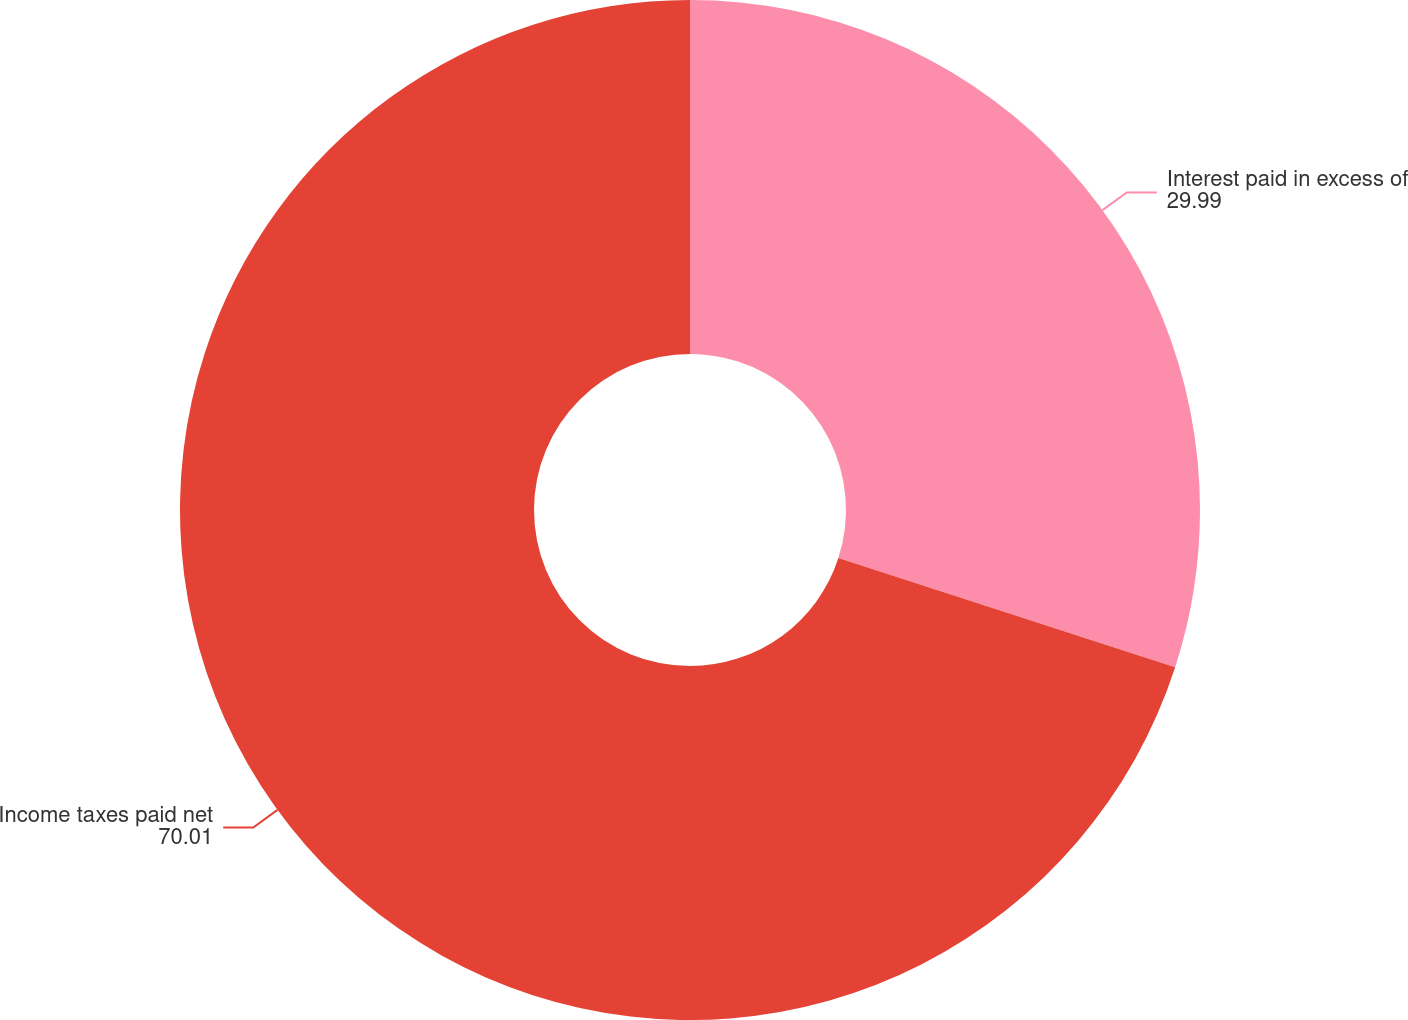<chart> <loc_0><loc_0><loc_500><loc_500><pie_chart><fcel>Interest paid in excess of<fcel>Income taxes paid net<nl><fcel>29.99%<fcel>70.01%<nl></chart> 